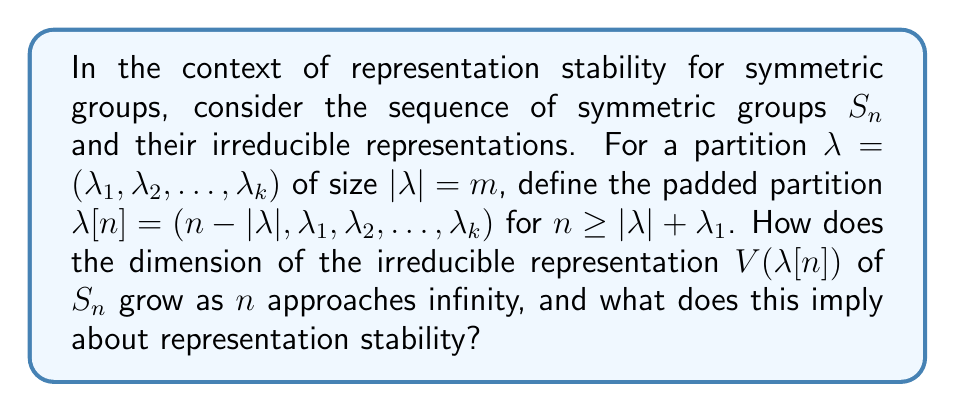Can you solve this math problem? To solve this problem, we'll follow these steps:

1) First, recall the hook-length formula for the dimension of an irreducible representation of $S_n$:

   $$\dim V(\lambda) = \frac{n!}{\prod_{(i,j) \in \lambda} h(i,j)}$$

   where $h(i,j)$ is the hook length of the box $(i,j)$ in the Young diagram of $\lambda$.

2) For the padded partition $\lambda[n] = (n-|\lambda|, \lambda_1, \lambda_2, \ldots, \lambda_k)$, we need to analyze how the hook lengths change as $n$ increases.

3) The crucial observation is that for large $n$, most of the hooks in the first row will have length approximately $n$, while the hooks in the remaining rows will stabilize.

4) More precisely, for the first row, we have:
   
   $$\prod_{j=1}^{n-|\lambda|} h(1,j) \approx n^{n-|\lambda|-\lambda_1} \cdot (n-|\lambda|)!$$

5) The product of hook lengths in the remaining rows will approach a constant $C$ as $n$ grows large.

6) Therefore, for large $n$, we can approximate:

   $$\dim V(\lambda[n]) \approx \frac{n!}{n^{n-|\lambda|-\lambda_1} \cdot (n-|\lambda|)! \cdot C}$$

7) Using Stirling's approximation, $n! \approx \sqrt{2\pi n} (n/e)^n$, we can further simplify:

   $$\dim V(\lambda[n]) \approx \frac{\sqrt{2\pi n} (n/e)^n}{n^{n-|\lambda|-\lambda_1} \cdot \sqrt{2\pi(n-|\lambda|)} ((n-|\lambda|)/e)^{n-|\lambda|} \cdot C}$$

8) After cancellation, we get:

   $$\dim V(\lambda[n]) \approx K \cdot n^{|\lambda|+\lambda_1-1/2}$$

   where $K$ is a constant independent of $n$.

9) This polynomial growth in $n$ implies representation stability. The exponent $|\lambda|+\lambda_1-1/2$ depends only on the original partition $\lambda$, not on $n$.
Answer: $\dim V(\lambda[n]) \sim O(n^{|\lambda|+\lambda_1-1/2})$ 